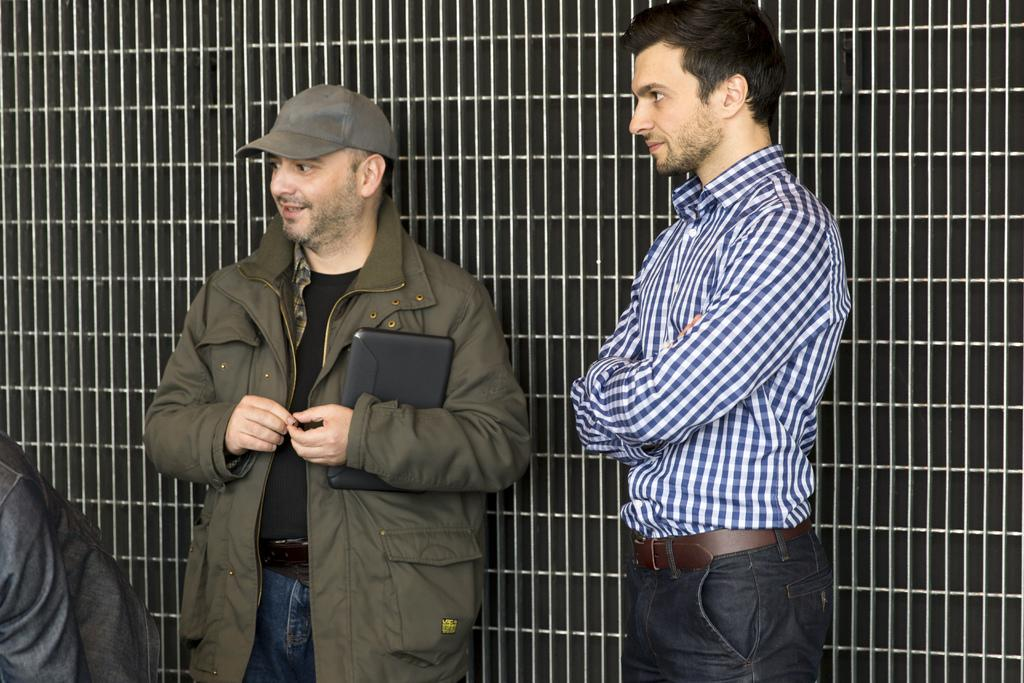How many people are present in the image? There are two persons standing in the image. Can you describe the background of the image? There are iron grilles visible in the background of the image. What song is being sung by the person on the left in the image? There is no indication in the image that a song is being sung, and we cannot determine the actions or expressions of the persons in the image. 